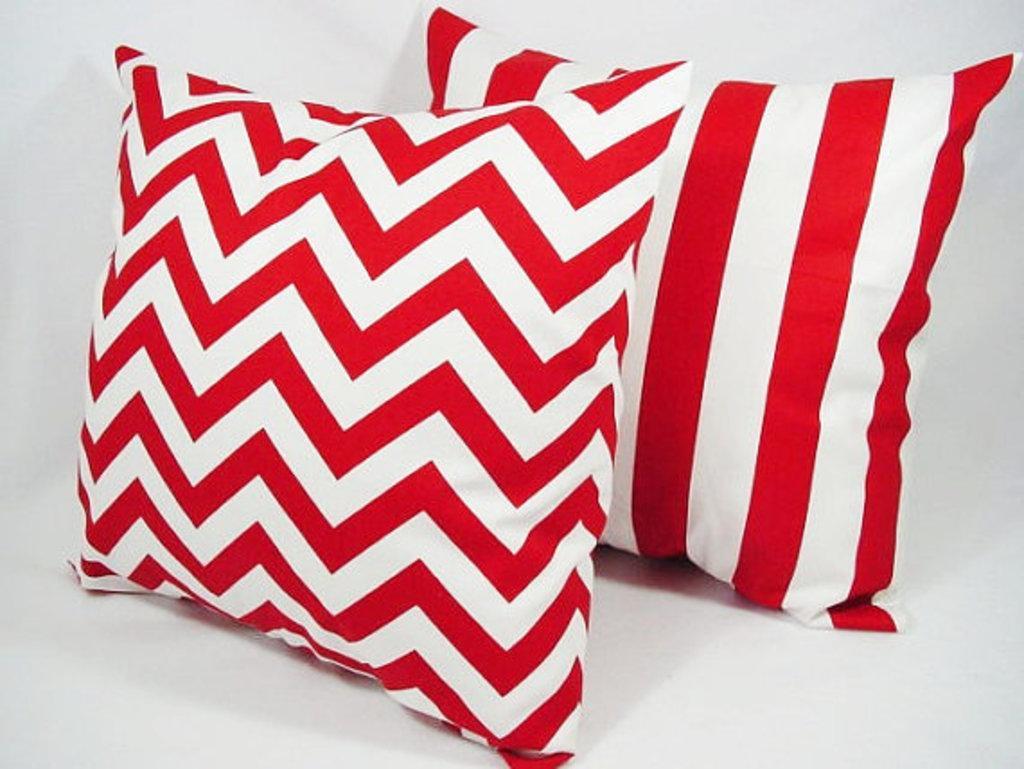Please provide a concise description of this image. In this image we can see two cushions, and the background is white in color. 